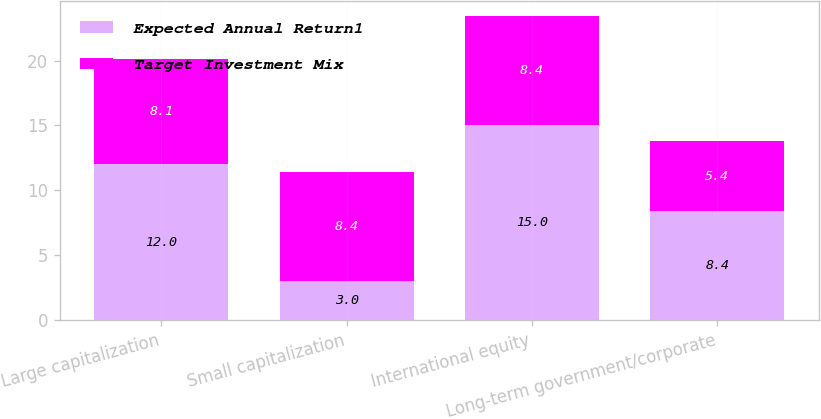Convert chart. <chart><loc_0><loc_0><loc_500><loc_500><stacked_bar_chart><ecel><fcel>Large capitalization<fcel>Small capitalization<fcel>International equity<fcel>Long-term government/corporate<nl><fcel>Expected Annual Return1<fcel>12<fcel>3<fcel>15<fcel>8.4<nl><fcel>Target Investment Mix<fcel>8.1<fcel>8.4<fcel>8.4<fcel>5.4<nl></chart> 